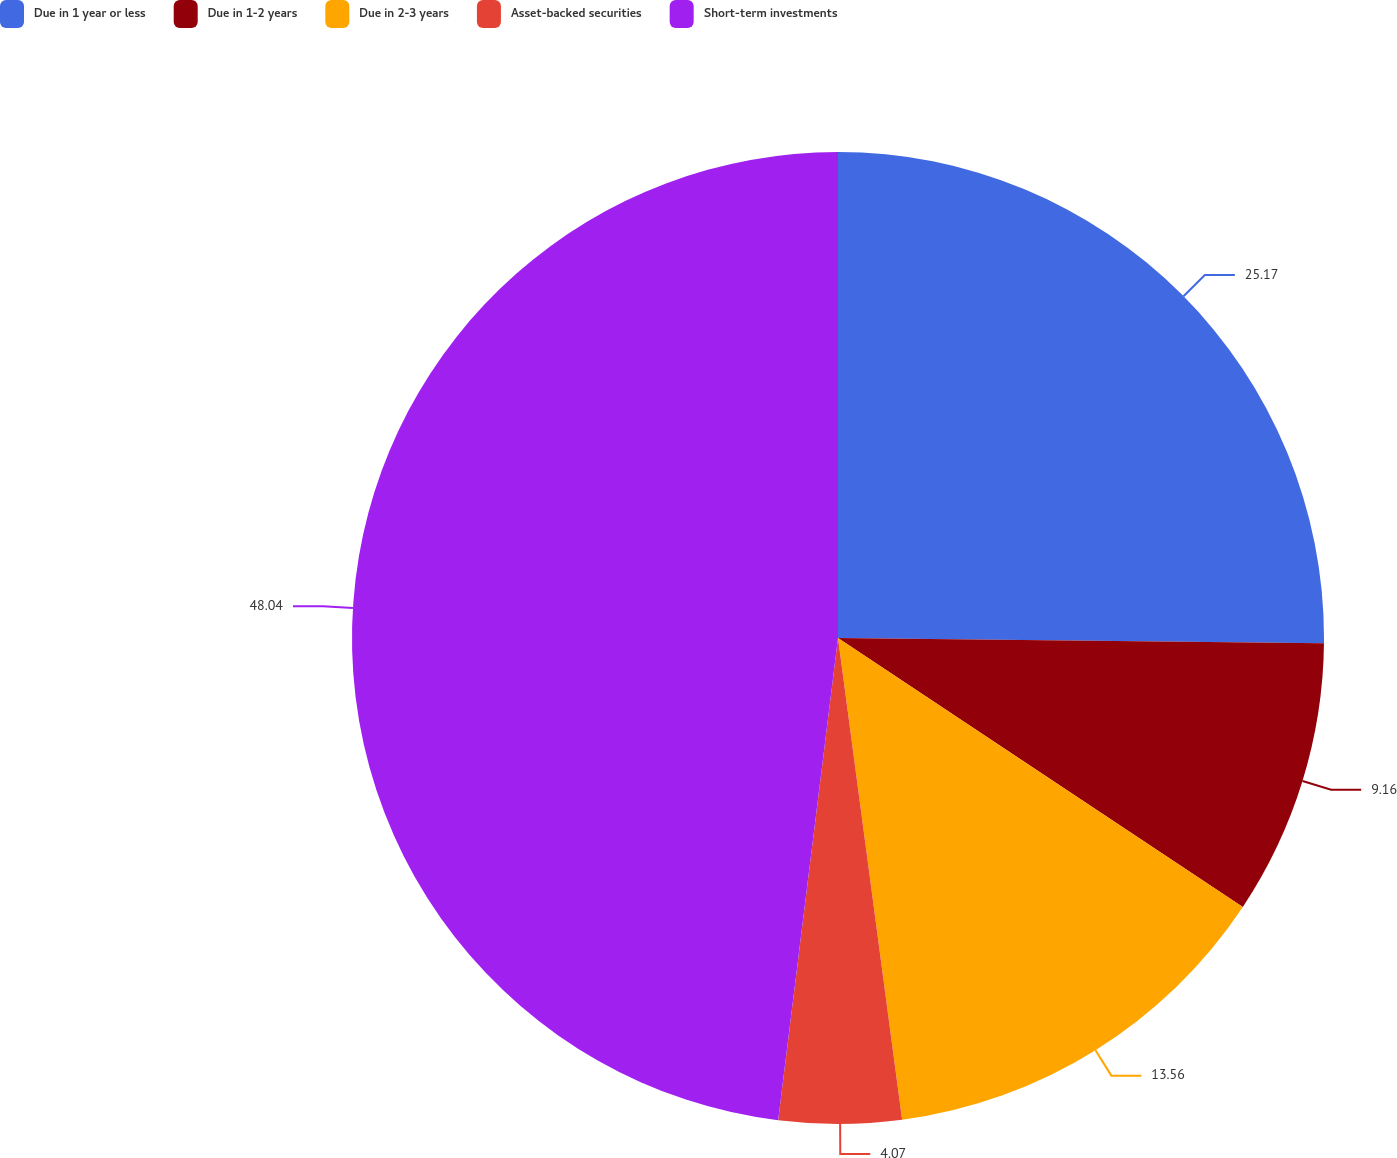Convert chart to OTSL. <chart><loc_0><loc_0><loc_500><loc_500><pie_chart><fcel>Due in 1 year or less<fcel>Due in 1-2 years<fcel>Due in 2-3 years<fcel>Asset-backed securities<fcel>Short-term investments<nl><fcel>25.17%<fcel>9.16%<fcel>13.56%<fcel>4.07%<fcel>48.03%<nl></chart> 